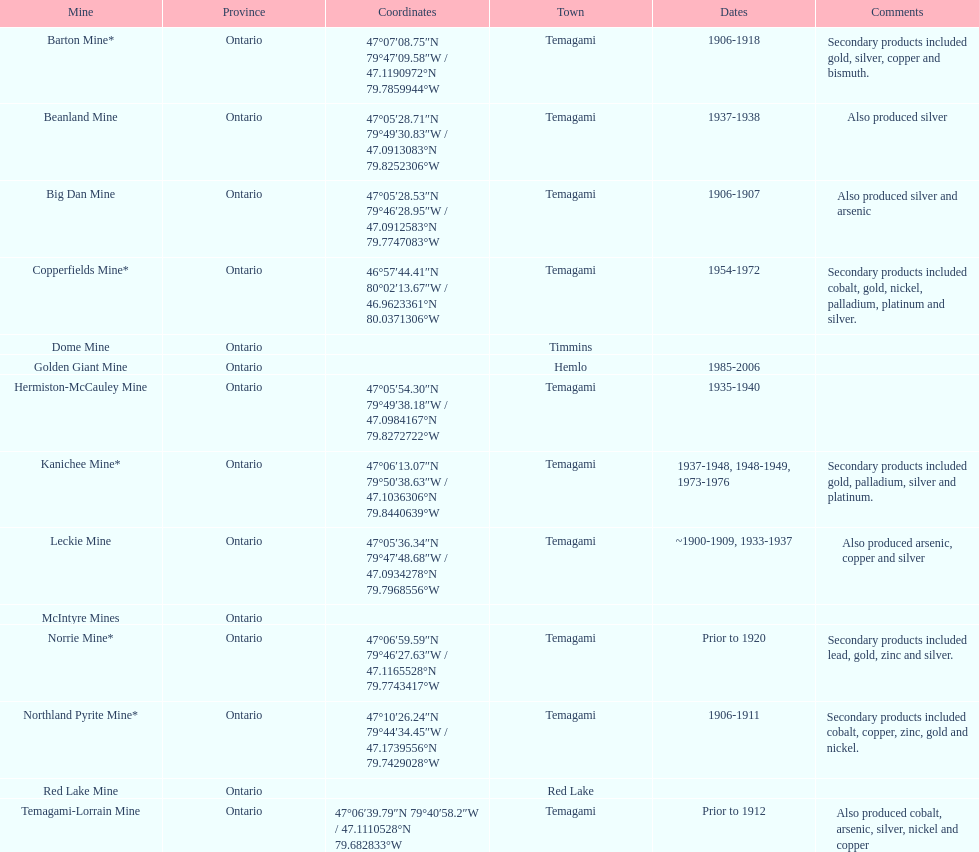How many times is temagami listedon the list? 10. Can you give me this table as a dict? {'header': ['Mine', 'Province', 'Coordinates', 'Town', 'Dates', 'Comments'], 'rows': [['Barton Mine*', 'Ontario', '47°07′08.75″N 79°47′09.58″W\ufeff / \ufeff47.1190972°N 79.7859944°W', 'Temagami', '1906-1918', 'Secondary products included gold, silver, copper and bismuth.'], ['Beanland Mine', 'Ontario', '47°05′28.71″N 79°49′30.83″W\ufeff / \ufeff47.0913083°N 79.8252306°W', 'Temagami', '1937-1938', 'Also produced silver'], ['Big Dan Mine', 'Ontario', '47°05′28.53″N 79°46′28.95″W\ufeff / \ufeff47.0912583°N 79.7747083°W', 'Temagami', '1906-1907', 'Also produced silver and arsenic'], ['Copperfields Mine*', 'Ontario', '46°57′44.41″N 80°02′13.67″W\ufeff / \ufeff46.9623361°N 80.0371306°W', 'Temagami', '1954-1972', 'Secondary products included cobalt, gold, nickel, palladium, platinum and silver.'], ['Dome Mine', 'Ontario', '', 'Timmins', '', ''], ['Golden Giant Mine', 'Ontario', '', 'Hemlo', '1985-2006', ''], ['Hermiston-McCauley Mine', 'Ontario', '47°05′54.30″N 79°49′38.18″W\ufeff / \ufeff47.0984167°N 79.8272722°W', 'Temagami', '1935-1940', ''], ['Kanichee Mine*', 'Ontario', '47°06′13.07″N 79°50′38.63″W\ufeff / \ufeff47.1036306°N 79.8440639°W', 'Temagami', '1937-1948, 1948-1949, 1973-1976', 'Secondary products included gold, palladium, silver and platinum.'], ['Leckie Mine', 'Ontario', '47°05′36.34″N 79°47′48.68″W\ufeff / \ufeff47.0934278°N 79.7968556°W', 'Temagami', '~1900-1909, 1933-1937', 'Also produced arsenic, copper and silver'], ['McIntyre Mines', 'Ontario', '', '', '', ''], ['Norrie Mine*', 'Ontario', '47°06′59.59″N 79°46′27.63″W\ufeff / \ufeff47.1165528°N 79.7743417°W', 'Temagami', 'Prior to 1920', 'Secondary products included lead, gold, zinc and silver.'], ['Northland Pyrite Mine*', 'Ontario', '47°10′26.24″N 79°44′34.45″W\ufeff / \ufeff47.1739556°N 79.7429028°W', 'Temagami', '1906-1911', 'Secondary products included cobalt, copper, zinc, gold and nickel.'], ['Red Lake Mine', 'Ontario', '', 'Red Lake', '', ''], ['Temagami-Lorrain Mine', 'Ontario', '47°06′39.79″N 79°40′58.2″W\ufeff / \ufeff47.1110528°N 79.682833°W', 'Temagami', 'Prior to 1912', 'Also produced cobalt, arsenic, silver, nickel and copper']]} 